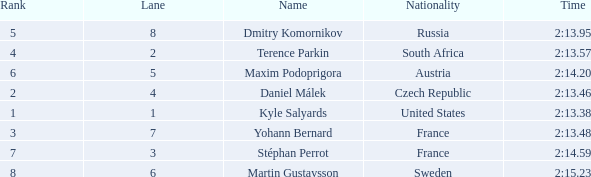What was Stéphan Perrot rank average? 7.0. 